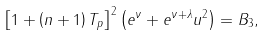Convert formula to latex. <formula><loc_0><loc_0><loc_500><loc_500>\left [ 1 + \left ( n + 1 \right ) T _ { p } \right ] ^ { 2 } \left ( e ^ { \nu } + e ^ { \nu + \lambda } u ^ { 2 } \right ) = B _ { 3 } ,</formula> 